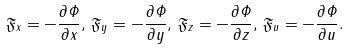<formula> <loc_0><loc_0><loc_500><loc_500>\mathfrak { F } _ { x } = - \frac { \partial \varPhi } { \partial x } , \, \mathfrak { F } _ { y } = - \frac { \partial \varPhi } { \partial y } , \, \mathfrak { F } _ { z } = - \frac { \partial \varPhi } { \partial z } , \, \mathfrak { F } _ { u } = - \frac { \partial \varPhi } { \partial u } .</formula> 